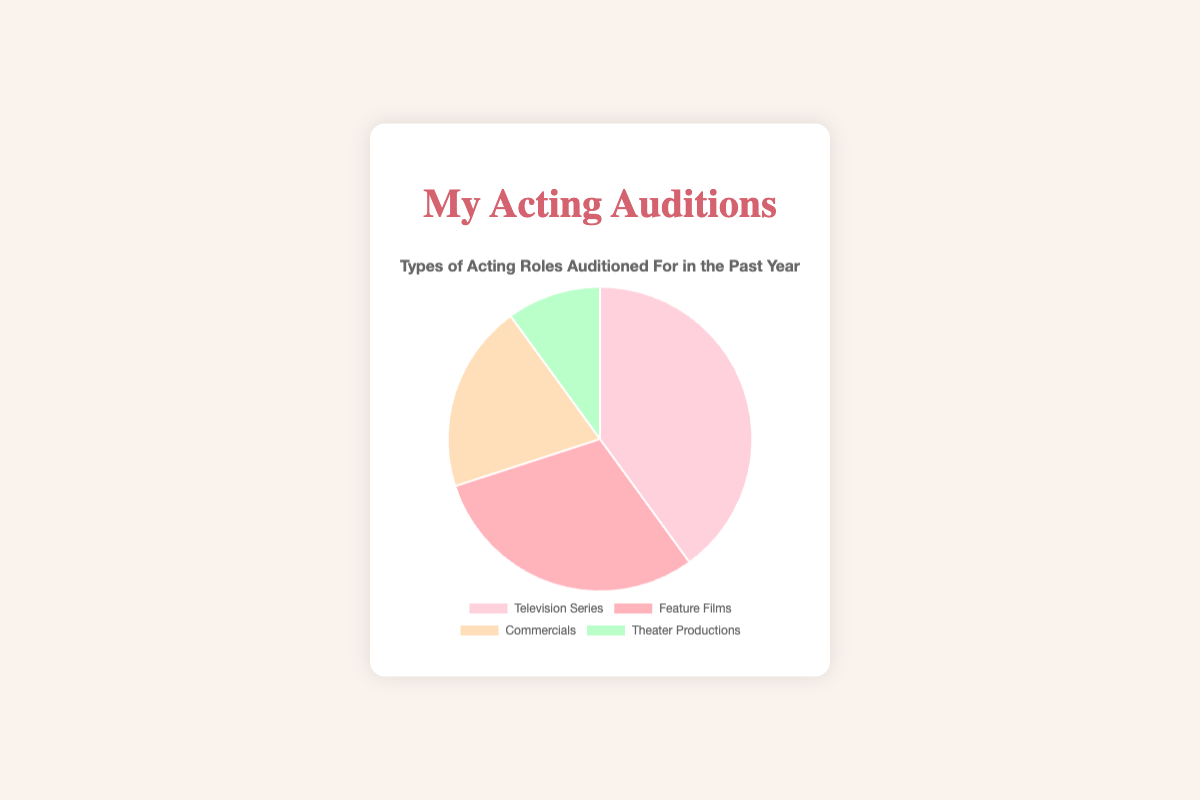What is the most auditioned role type? The Pie chart shows the proportion of each role type auditioned for, and the largest segment corresponds to Television Series with a percentage of 40%.
Answer: Television Series What percentage of auditions were for Theater Productions? From the chart, the section for Theater Productions is marked with a percentage, indicating it took up 10% of the total auditions.
Answer: 10% How does the percentage of auditions for Commercials compare to Feature Films? By comparing the sections of the pie chart, we see that Commercials have a smaller percentage (20%) compared to Feature Films (30%).
Answer: Feature Films have a higher percentage What is the combined percentage of auditions for Television Series and Feature Films? To find the combined percentage, sum up the individual percentages: 40% for Television Series and 30% for Feature Films, which equals 70%.
Answer: 70% Which role type has the smallest proportion of auditions? The smallest section in the pie chart represents Theater Productions, which is 10% of the total auditions.
Answer: Theater Productions If you were to remove Theater Productions from the chart, what would be the new percentage distribution for each remaining role type? Removing Theater Productions (10%) leaves us with 90% for the other roles. Recalculate the percentages by normalizing: Television Series 40/90 ≈ 44.44%, Feature Films 30/90 ≈ 33.33%, Commercials 20/90 ≈ 22.22%.
Answer: Television Series 44.44%, Feature Films 33.33%, Commercials 22.22% What is the difference in percentage points between the most and least auditioned role types? The most auditioned role type is Television Series at 40%, and the least is Theater Productions at 10%. The difference is 40% - 10% = 30%.
Answer: 30% How many times larger is the proportion of Television Series auditions compared to Theater Productions? To find the ratio, divide the percentage of Television Series by Theater Productions: 40% / 10% = 4. So, Television Series auditions are 4 times larger.
Answer: 4 times In terms of visual appearance, which color is associated with the largest segment in the pie chart? The largest segment corresponds to Television Series, which is colored pink.
Answer: Pink 